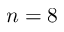Convert formula to latex. <formula><loc_0><loc_0><loc_500><loc_500>n = 8</formula> 